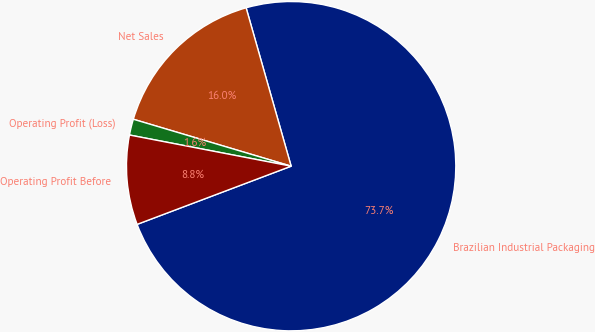Convert chart. <chart><loc_0><loc_0><loc_500><loc_500><pie_chart><fcel>Brazilian Industrial Packaging<fcel>Net Sales<fcel>Operating Profit (Loss)<fcel>Operating Profit Before<nl><fcel>73.66%<fcel>15.99%<fcel>1.57%<fcel>8.78%<nl></chart> 